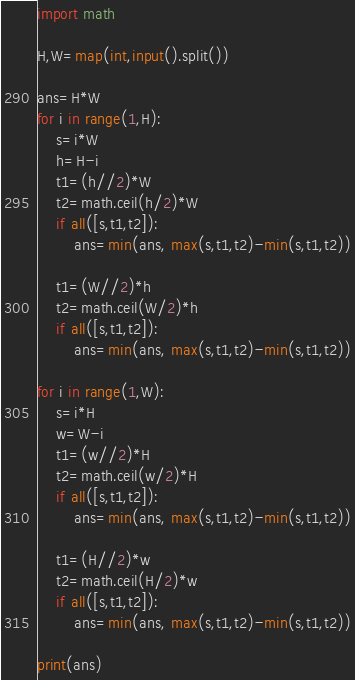Convert code to text. <code><loc_0><loc_0><loc_500><loc_500><_Python_>import math

H,W=map(int,input().split())

ans=H*W
for i in range(1,H):
	s=i*W
	h=H-i
	t1=(h//2)*W
	t2=math.ceil(h/2)*W
	if all([s,t1,t2]):
		ans=min(ans, max(s,t1,t2)-min(s,t1,t2))
	
	t1=(W//2)*h
	t2=math.ceil(W/2)*h
	if all([s,t1,t2]):
		ans=min(ans, max(s,t1,t2)-min(s,t1,t2))

for i in range(1,W):
	s=i*H
	w=W-i
	t1=(w//2)*H
	t2=math.ceil(w/2)*H
	if all([s,t1,t2]):
		ans=min(ans, max(s,t1,t2)-min(s,t1,t2))
	
	t1=(H//2)*w
	t2=math.ceil(H/2)*w
	if all([s,t1,t2]):
		ans=min(ans, max(s,t1,t2)-min(s,t1,t2))

print(ans)</code> 